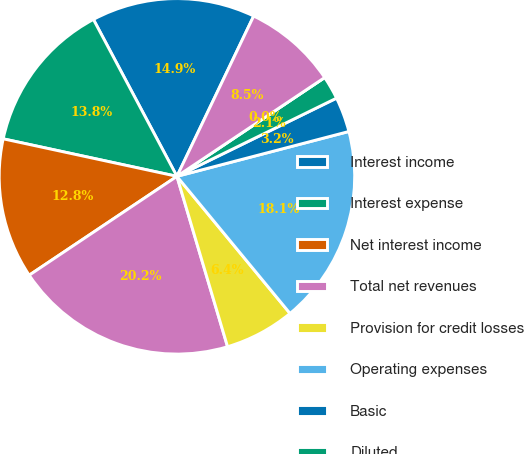Convert chart. <chart><loc_0><loc_0><loc_500><loc_500><pie_chart><fcel>Interest income<fcel>Interest expense<fcel>Net interest income<fcel>Total net revenues<fcel>Provision for credit losses<fcel>Operating expenses<fcel>Basic<fcel>Diluted<fcel>Dividends declared per common<fcel>Basic shares<nl><fcel>14.89%<fcel>13.83%<fcel>12.77%<fcel>20.21%<fcel>6.38%<fcel>18.08%<fcel>3.19%<fcel>2.13%<fcel>0.0%<fcel>8.51%<nl></chart> 